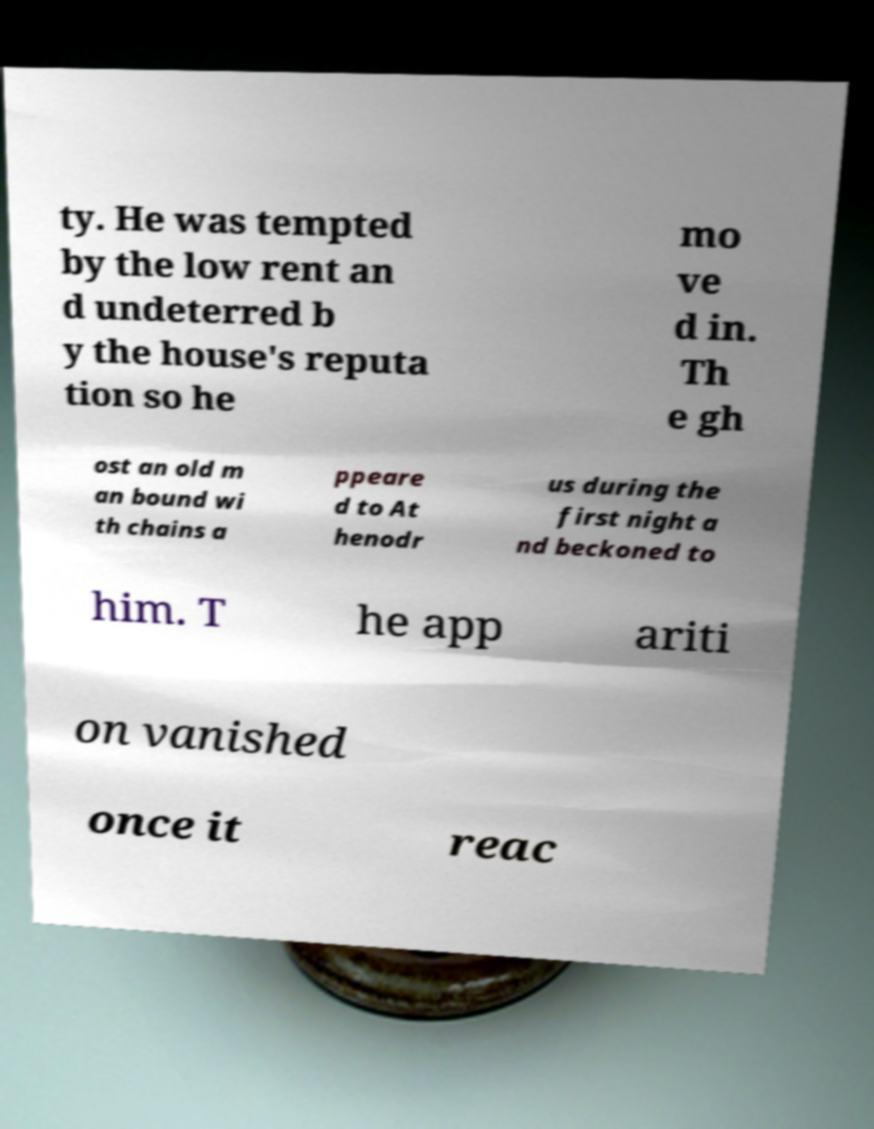Please read and relay the text visible in this image. What does it say? ty. He was tempted by the low rent an d undeterred b y the house's reputa tion so he mo ve d in. Th e gh ost an old m an bound wi th chains a ppeare d to At henodr us during the first night a nd beckoned to him. T he app ariti on vanished once it reac 